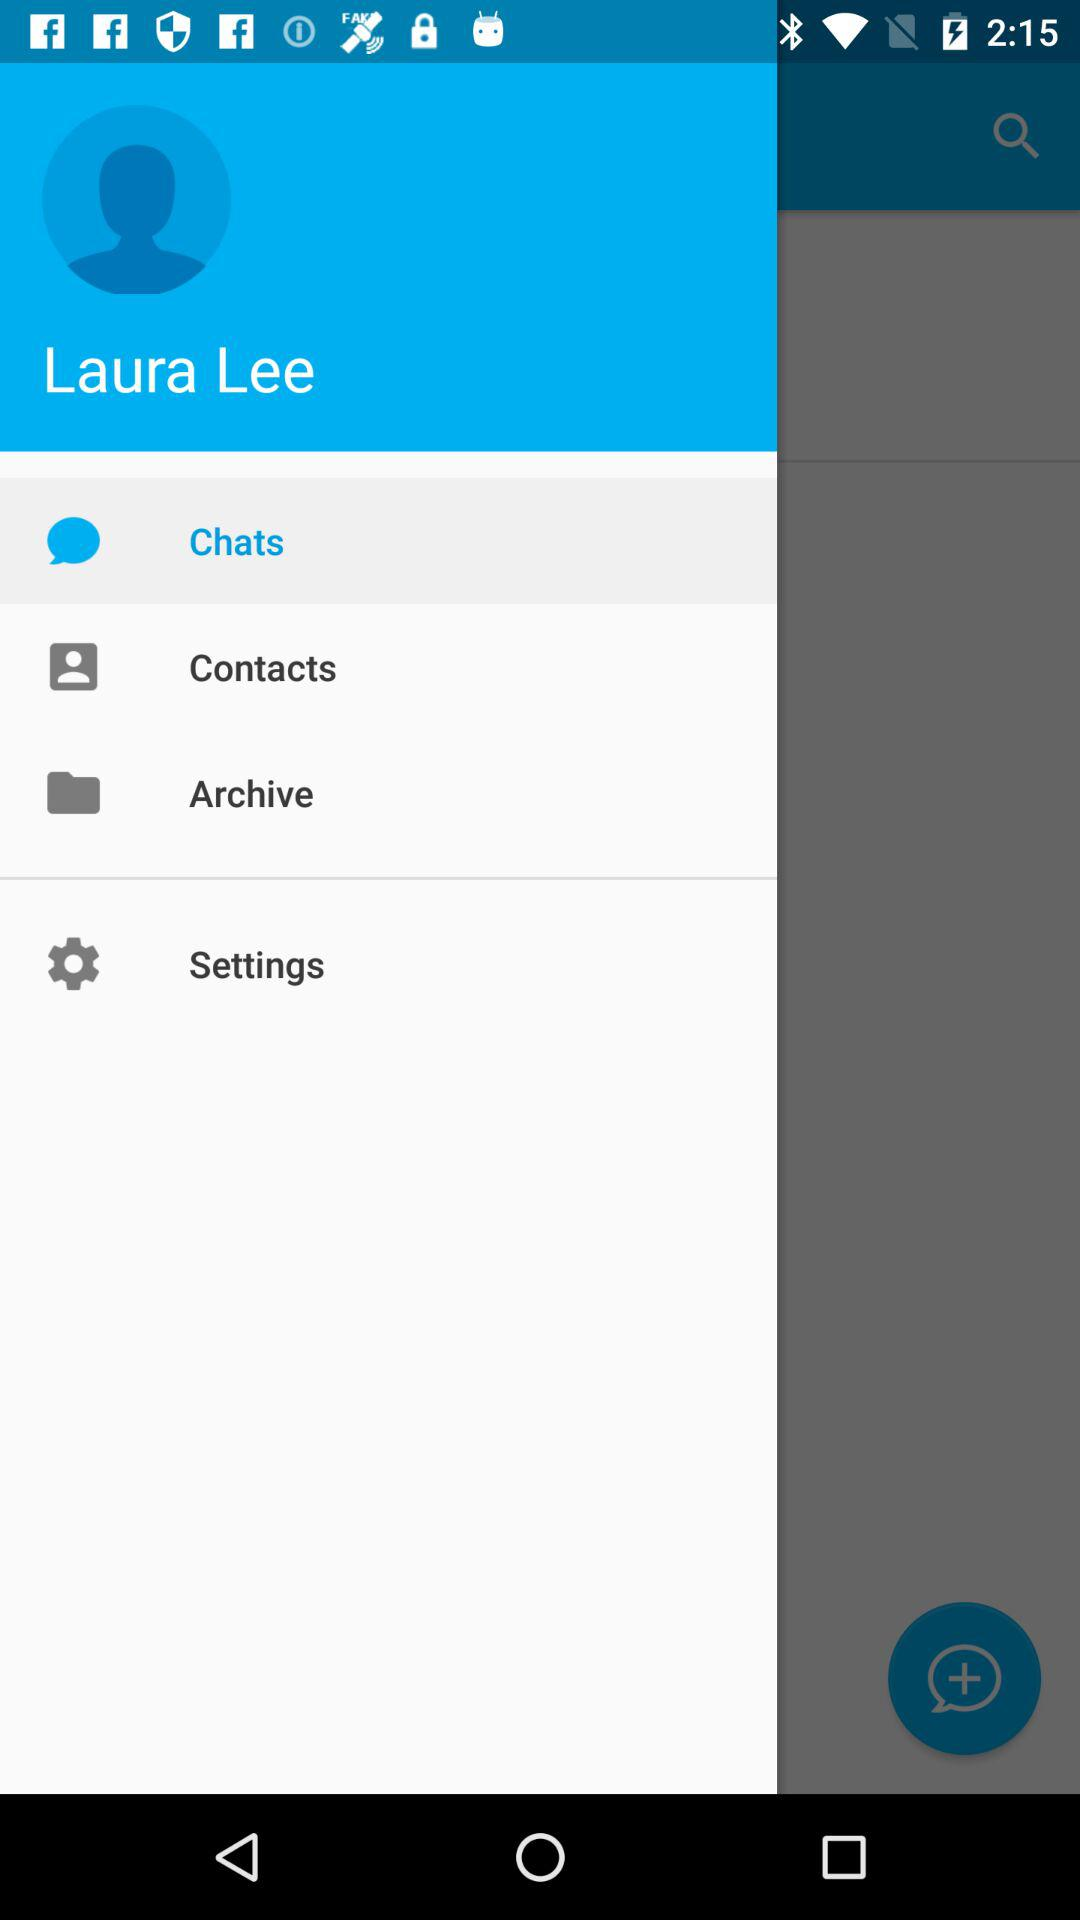When was the last chat message sent?
When the provided information is insufficient, respond with <no answer>. <no answer> 